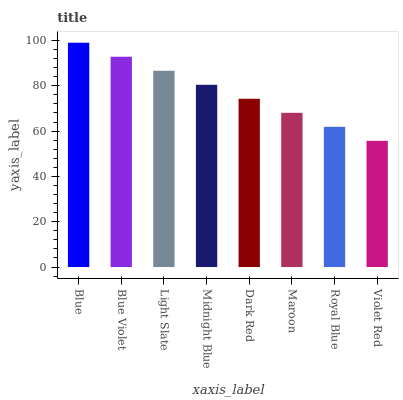Is Violet Red the minimum?
Answer yes or no. Yes. Is Blue the maximum?
Answer yes or no. Yes. Is Blue Violet the minimum?
Answer yes or no. No. Is Blue Violet the maximum?
Answer yes or no. No. Is Blue greater than Blue Violet?
Answer yes or no. Yes. Is Blue Violet less than Blue?
Answer yes or no. Yes. Is Blue Violet greater than Blue?
Answer yes or no. No. Is Blue less than Blue Violet?
Answer yes or no. No. Is Midnight Blue the high median?
Answer yes or no. Yes. Is Dark Red the low median?
Answer yes or no. Yes. Is Blue the high median?
Answer yes or no. No. Is Light Slate the low median?
Answer yes or no. No. 